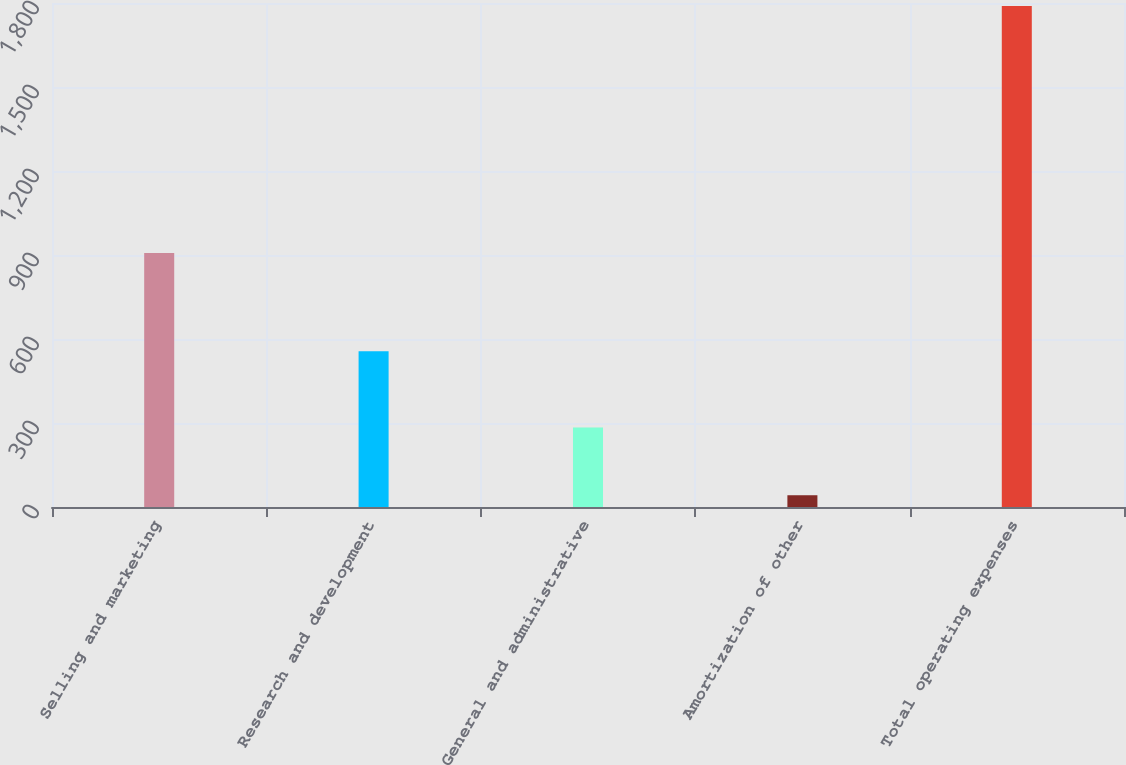Convert chart to OTSL. <chart><loc_0><loc_0><loc_500><loc_500><bar_chart><fcel>Selling and marketing<fcel>Research and development<fcel>General and administrative<fcel>Amortization of other<fcel>Total operating expenses<nl><fcel>907<fcel>556<fcel>284<fcel>42<fcel>1789<nl></chart> 